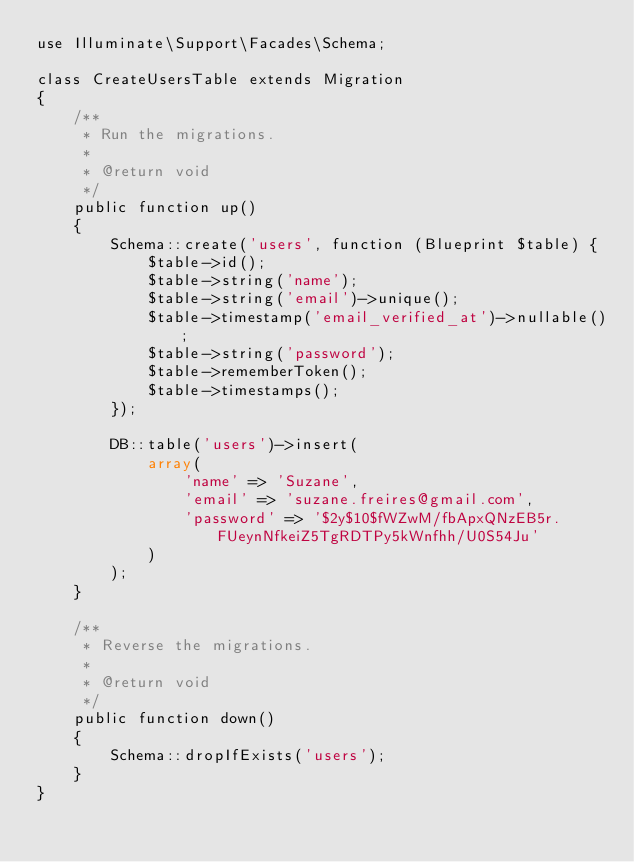<code> <loc_0><loc_0><loc_500><loc_500><_PHP_>use Illuminate\Support\Facades\Schema;

class CreateUsersTable extends Migration
{
    /**
     * Run the migrations.
     *
     * @return void
     */
    public function up()
    {
        Schema::create('users', function (Blueprint $table) {
            $table->id();
            $table->string('name');
            $table->string('email')->unique();
            $table->timestamp('email_verified_at')->nullable();
            $table->string('password');
            $table->rememberToken();
            $table->timestamps();
        });

        DB::table('users')->insert(
            array(
                'name' => 'Suzane',
                'email' => 'suzane.freires@gmail.com',
                'password' => '$2y$10$fWZwM/fbApxQNzEB5r.FUeynNfkeiZ5TgRDTPy5kWnfhh/U0S54Ju'
            )
        );
    }

    /**
     * Reverse the migrations.
     *
     * @return void
     */
    public function down()
    {
        Schema::dropIfExists('users');
    }
}
</code> 